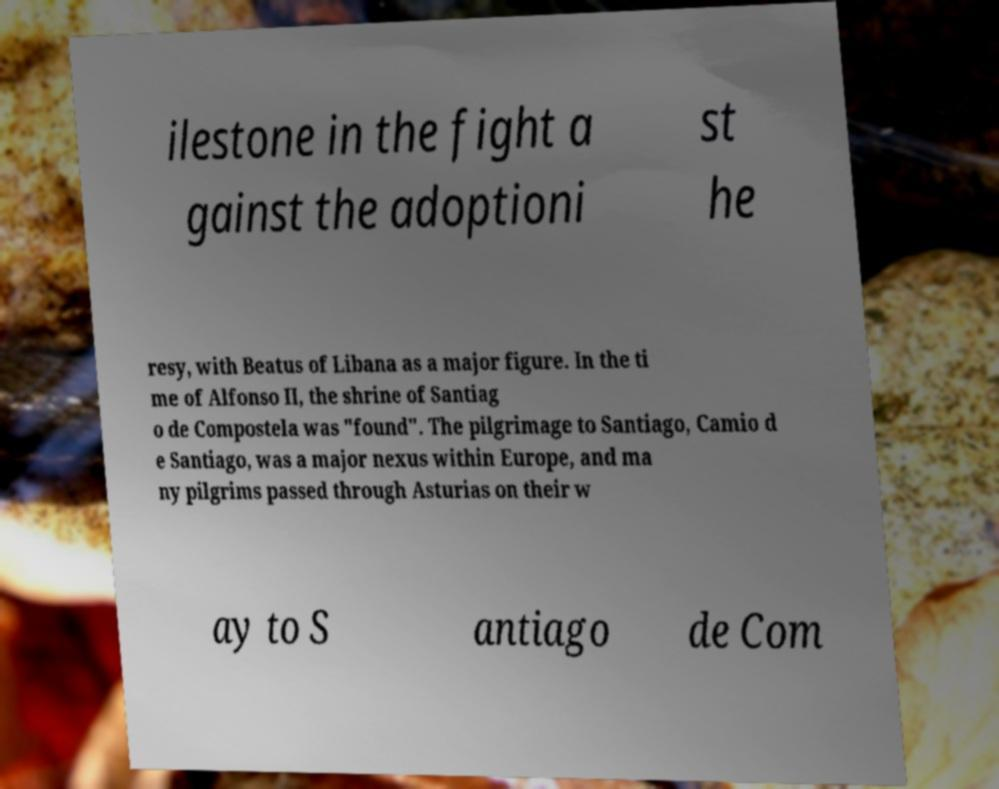There's text embedded in this image that I need extracted. Can you transcribe it verbatim? ilestone in the fight a gainst the adoptioni st he resy, with Beatus of Libana as a major figure. In the ti me of Alfonso II, the shrine of Santiag o de Compostela was "found". The pilgrimage to Santiago, Camio d e Santiago, was a major nexus within Europe, and ma ny pilgrims passed through Asturias on their w ay to S antiago de Com 